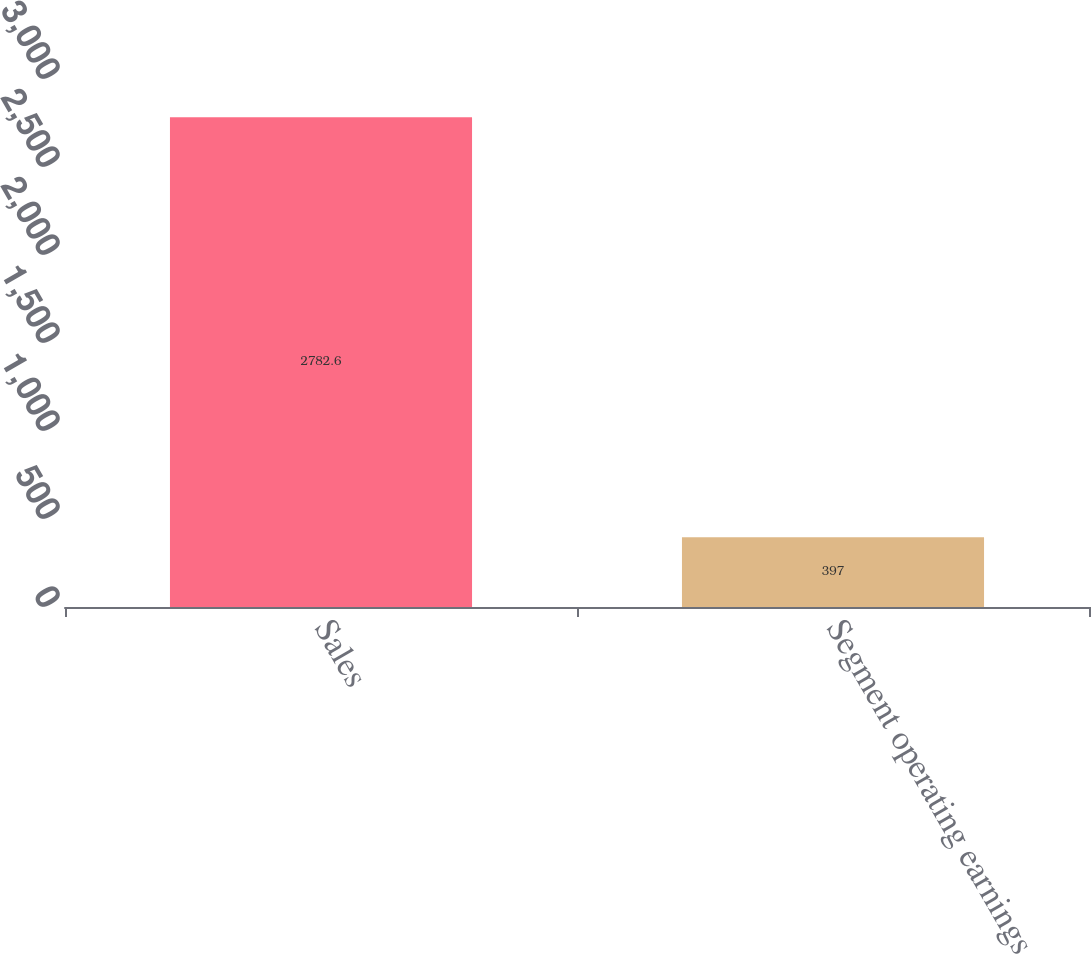Convert chart to OTSL. <chart><loc_0><loc_0><loc_500><loc_500><bar_chart><fcel>Sales<fcel>Segment operating earnings<nl><fcel>2782.6<fcel>397<nl></chart> 